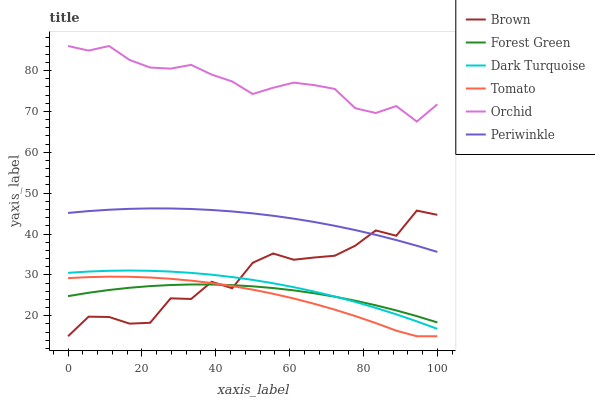Does Tomato have the minimum area under the curve?
Answer yes or no. Yes. Does Orchid have the maximum area under the curve?
Answer yes or no. Yes. Does Brown have the minimum area under the curve?
Answer yes or no. No. Does Brown have the maximum area under the curve?
Answer yes or no. No. Is Periwinkle the smoothest?
Answer yes or no. Yes. Is Brown the roughest?
Answer yes or no. Yes. Is Dark Turquoise the smoothest?
Answer yes or no. No. Is Dark Turquoise the roughest?
Answer yes or no. No. Does Tomato have the lowest value?
Answer yes or no. Yes. Does Dark Turquoise have the lowest value?
Answer yes or no. No. Does Orchid have the highest value?
Answer yes or no. Yes. Does Brown have the highest value?
Answer yes or no. No. Is Forest Green less than Periwinkle?
Answer yes or no. Yes. Is Orchid greater than Forest Green?
Answer yes or no. Yes. Does Tomato intersect Brown?
Answer yes or no. Yes. Is Tomato less than Brown?
Answer yes or no. No. Is Tomato greater than Brown?
Answer yes or no. No. Does Forest Green intersect Periwinkle?
Answer yes or no. No. 